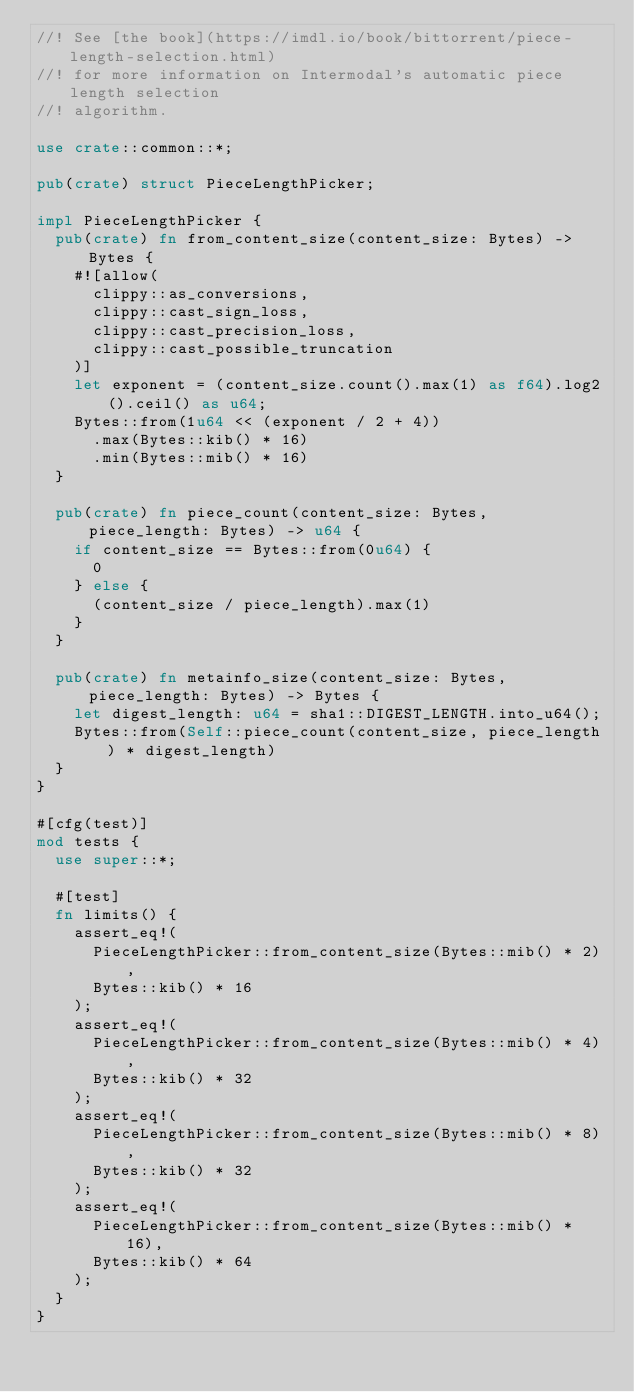<code> <loc_0><loc_0><loc_500><loc_500><_Rust_>//! See [the book](https://imdl.io/book/bittorrent/piece-length-selection.html)
//! for more information on Intermodal's automatic piece length selection
//! algorithm.

use crate::common::*;

pub(crate) struct PieceLengthPicker;

impl PieceLengthPicker {
  pub(crate) fn from_content_size(content_size: Bytes) -> Bytes {
    #![allow(
      clippy::as_conversions,
      clippy::cast_sign_loss,
      clippy::cast_precision_loss,
      clippy::cast_possible_truncation
    )]
    let exponent = (content_size.count().max(1) as f64).log2().ceil() as u64;
    Bytes::from(1u64 << (exponent / 2 + 4))
      .max(Bytes::kib() * 16)
      .min(Bytes::mib() * 16)
  }

  pub(crate) fn piece_count(content_size: Bytes, piece_length: Bytes) -> u64 {
    if content_size == Bytes::from(0u64) {
      0
    } else {
      (content_size / piece_length).max(1)
    }
  }

  pub(crate) fn metainfo_size(content_size: Bytes, piece_length: Bytes) -> Bytes {
    let digest_length: u64 = sha1::DIGEST_LENGTH.into_u64();
    Bytes::from(Self::piece_count(content_size, piece_length) * digest_length)
  }
}

#[cfg(test)]
mod tests {
  use super::*;

  #[test]
  fn limits() {
    assert_eq!(
      PieceLengthPicker::from_content_size(Bytes::mib() * 2),
      Bytes::kib() * 16
    );
    assert_eq!(
      PieceLengthPicker::from_content_size(Bytes::mib() * 4),
      Bytes::kib() * 32
    );
    assert_eq!(
      PieceLengthPicker::from_content_size(Bytes::mib() * 8),
      Bytes::kib() * 32
    );
    assert_eq!(
      PieceLengthPicker::from_content_size(Bytes::mib() * 16),
      Bytes::kib() * 64
    );
  }
}
</code> 